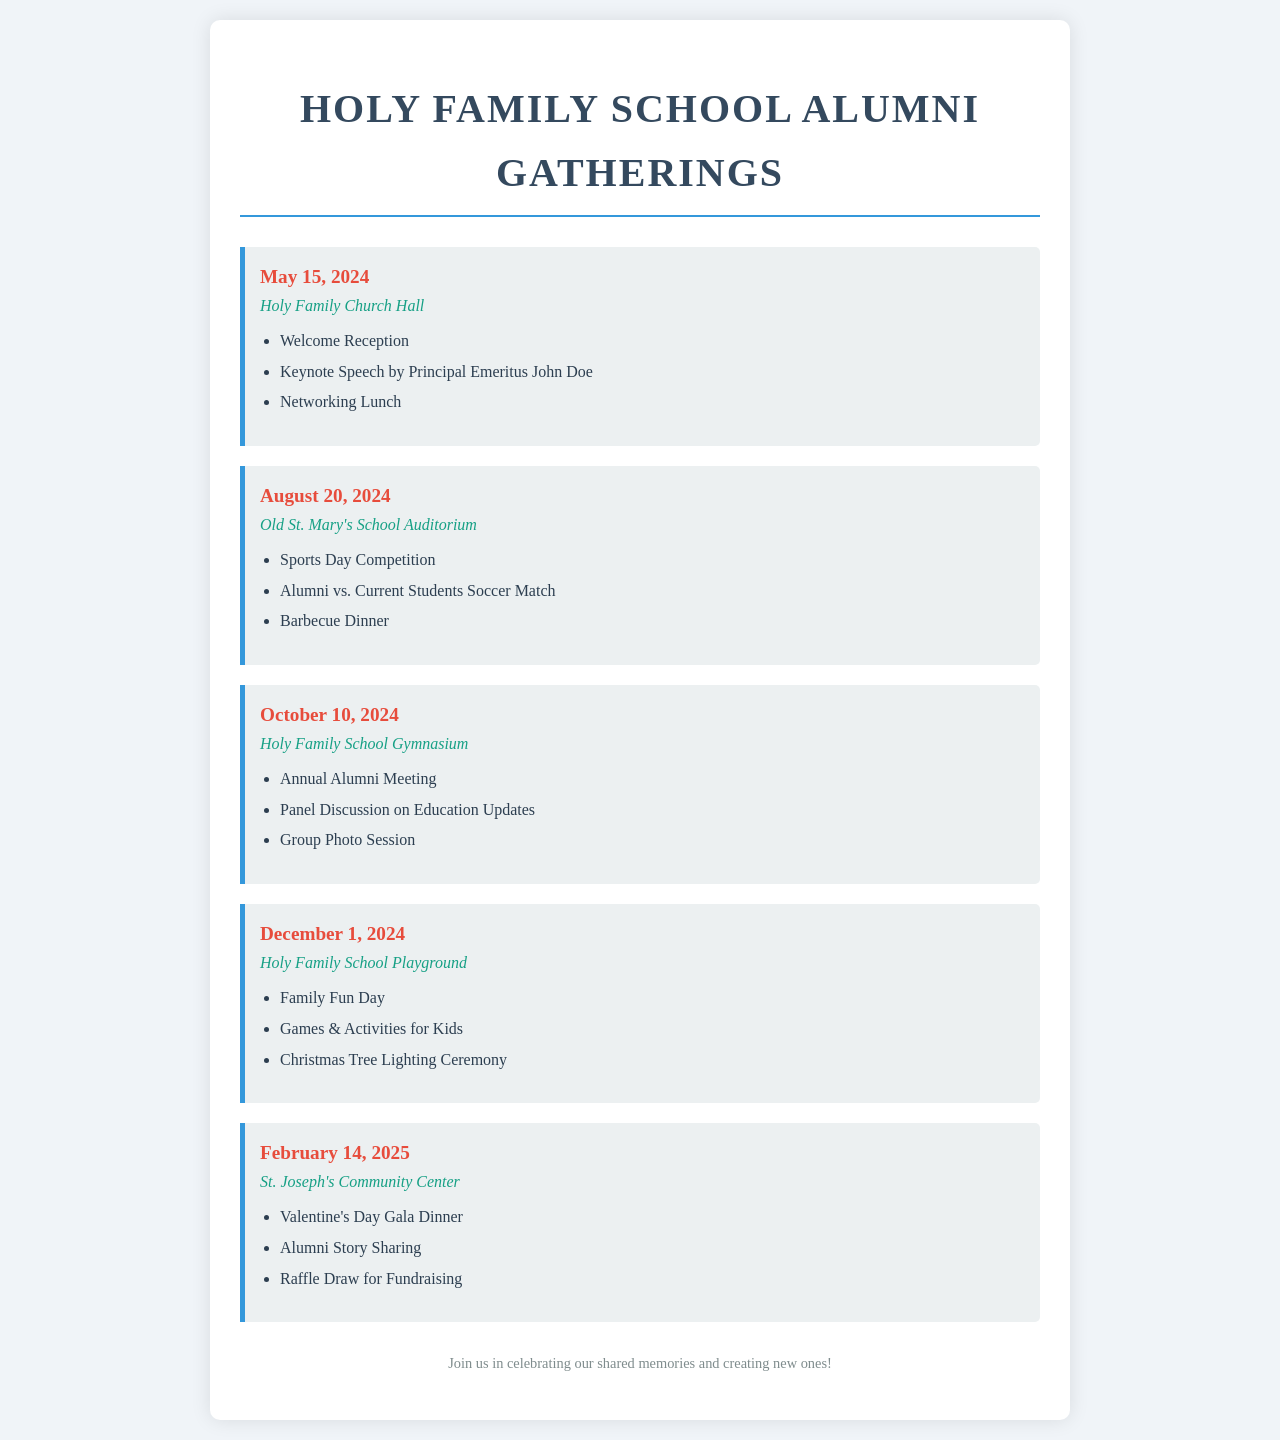What is the date of the first alumni gathering? The first alumni gathering is scheduled for May 15, 2024.
Answer: May 15, 2024 Where will the August gathering take place? The August gathering will take place at Old St. Mary's School Auditorium.
Answer: Old St. Mary's School Auditorium What major activity is planned for the October gathering? A major activity planned for the October gathering is the Annual Alumni Meeting.
Answer: Annual Alumni Meeting How many activities are listed for the Family Fun Day? The Family Fun Day has three activities planned.
Answer: 3 Which venue is hosting the Valentine's Day Gala Dinner? The Valentine's Day Gala Dinner will be hosted at St. Joseph's Community Center.
Answer: St. Joseph's Community Center What is the main theme of the December 1 gathering? The main theme of the December 1 gathering is Family Fun Day.
Answer: Family Fun Day What is the color of the date text for events? The date text color for events is red.
Answer: Red 